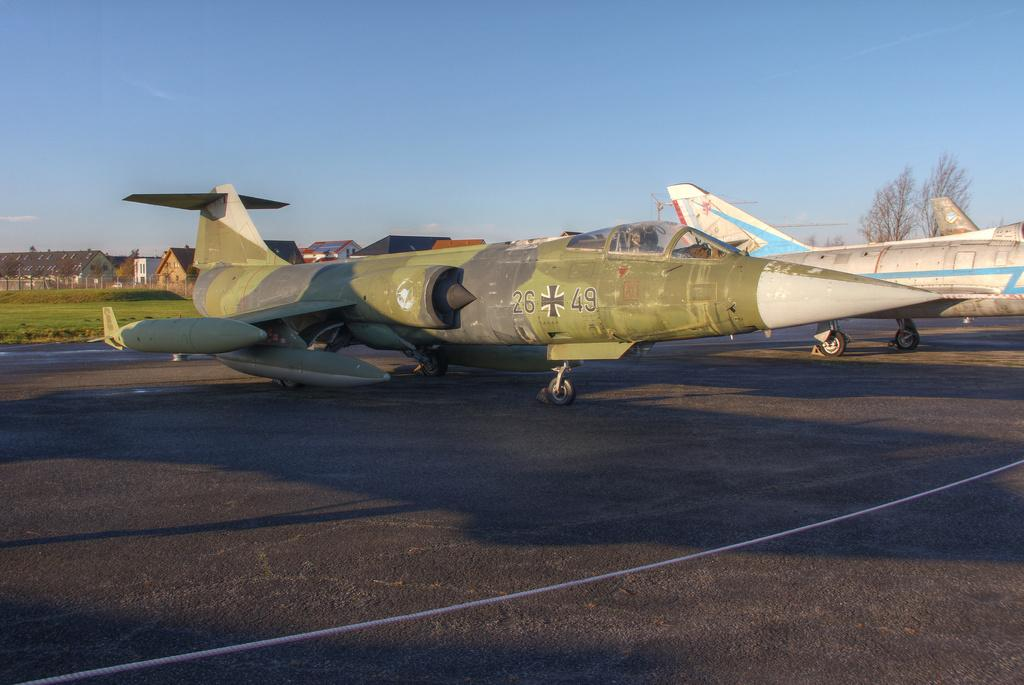Provide a one-sentence caption for the provided image. An old jet has the numbers 26 and 49 on the side, with a symbol in between. 